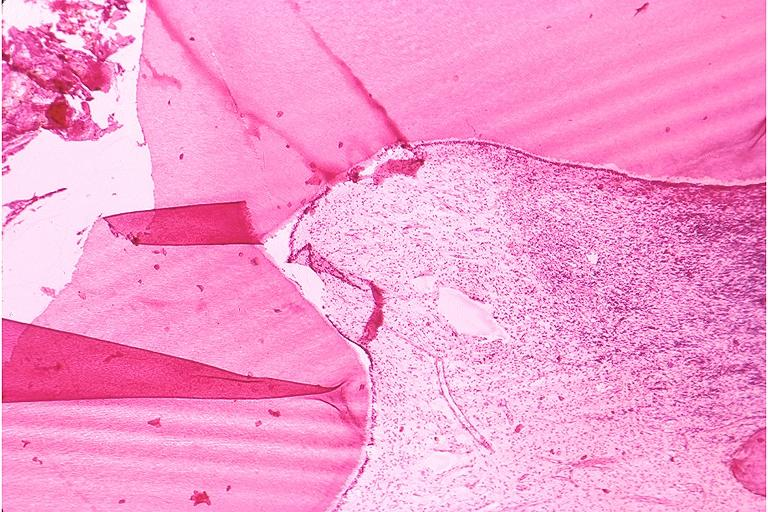what does this image show?
Answer the question using a single word or phrase. Chronic pulpitis 